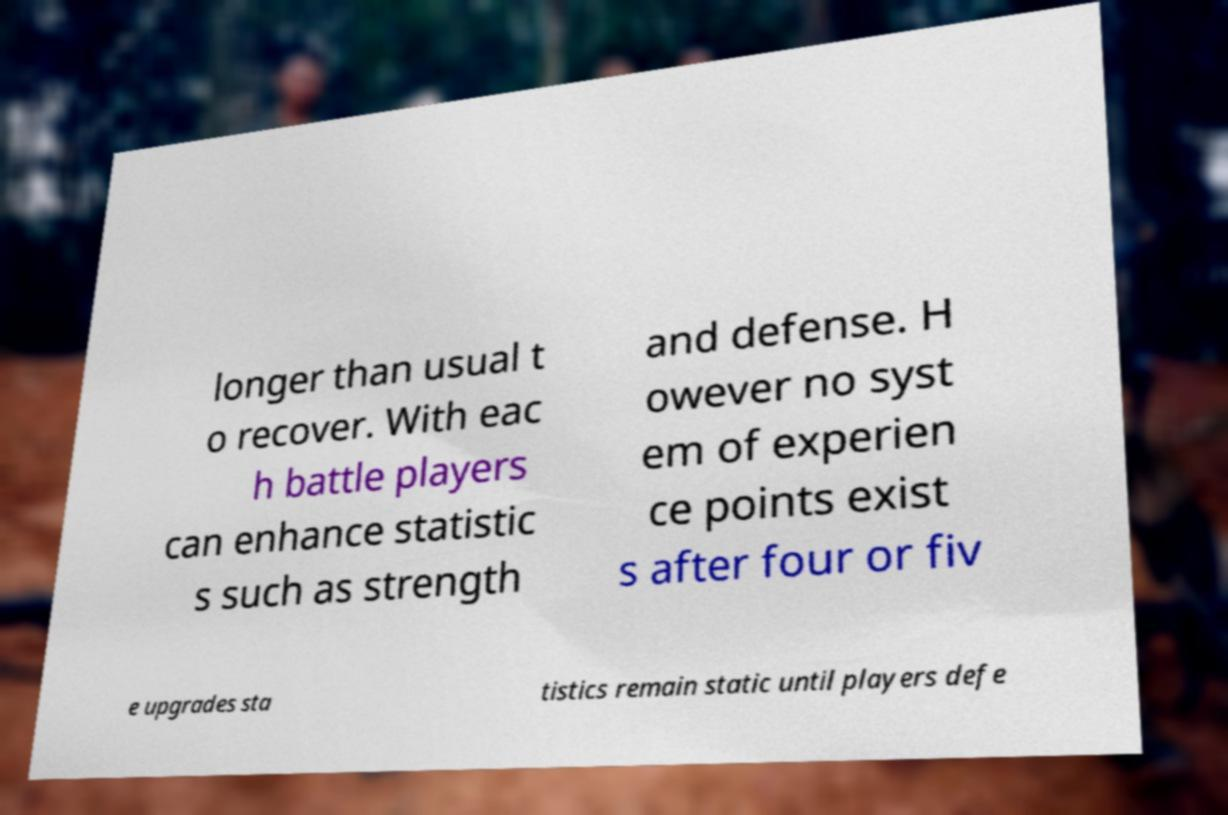Could you assist in decoding the text presented in this image and type it out clearly? longer than usual t o recover. With eac h battle players can enhance statistic s such as strength and defense. H owever no syst em of experien ce points exist s after four or fiv e upgrades sta tistics remain static until players defe 